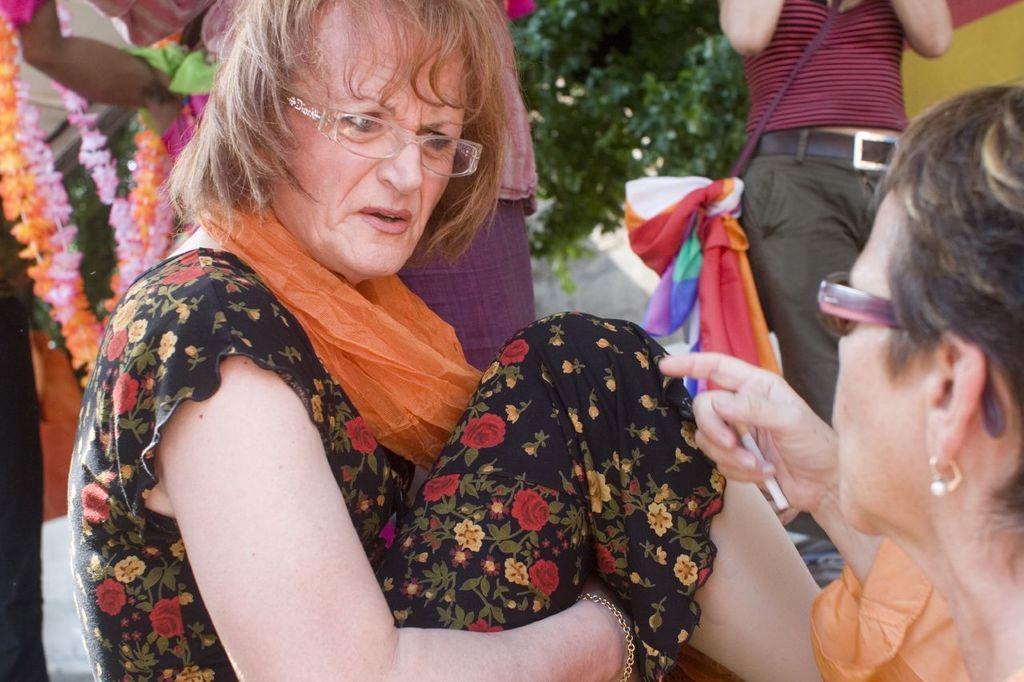Please provide a concise description of this image. In this image I can see a woman wearing orange and black colored dress is sitting and I can see another woman holding a cigarette on the right side of the image. In the background I can see few persons standing, few flower garlands and a tree which is green in color. 